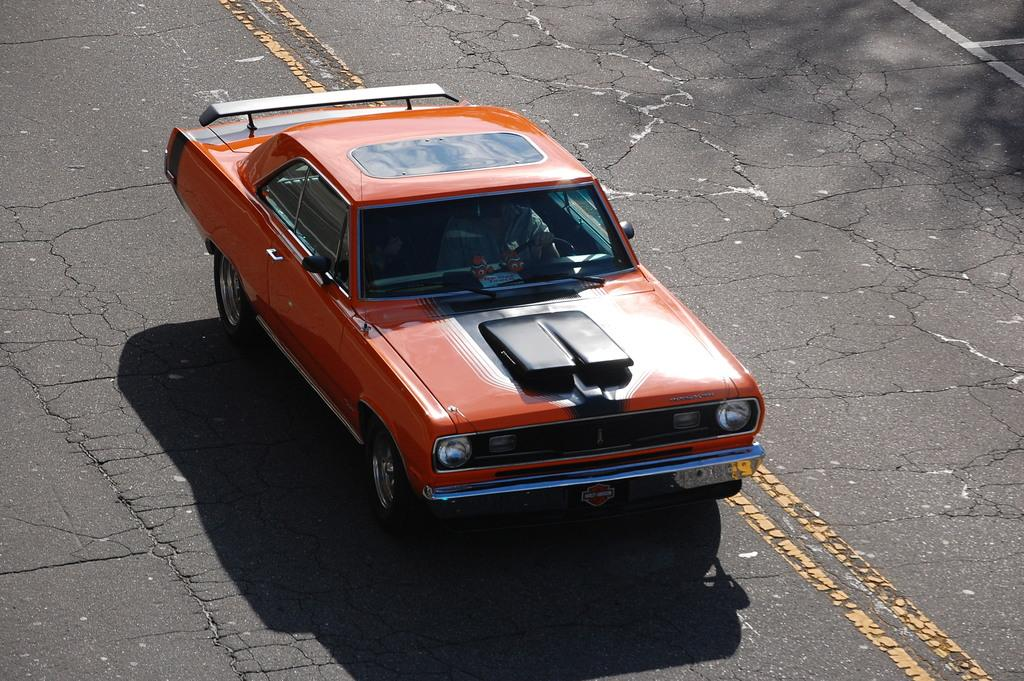Who is inside the car in the image? There is a person in the car. Where is the car located in the image? The car is on the road. What type of dinner is being served to the visitor in the image? There is no dinner or visitor present in the image; it only shows a person in a car on the road. 